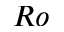<formula> <loc_0><loc_0><loc_500><loc_500>R o</formula> 